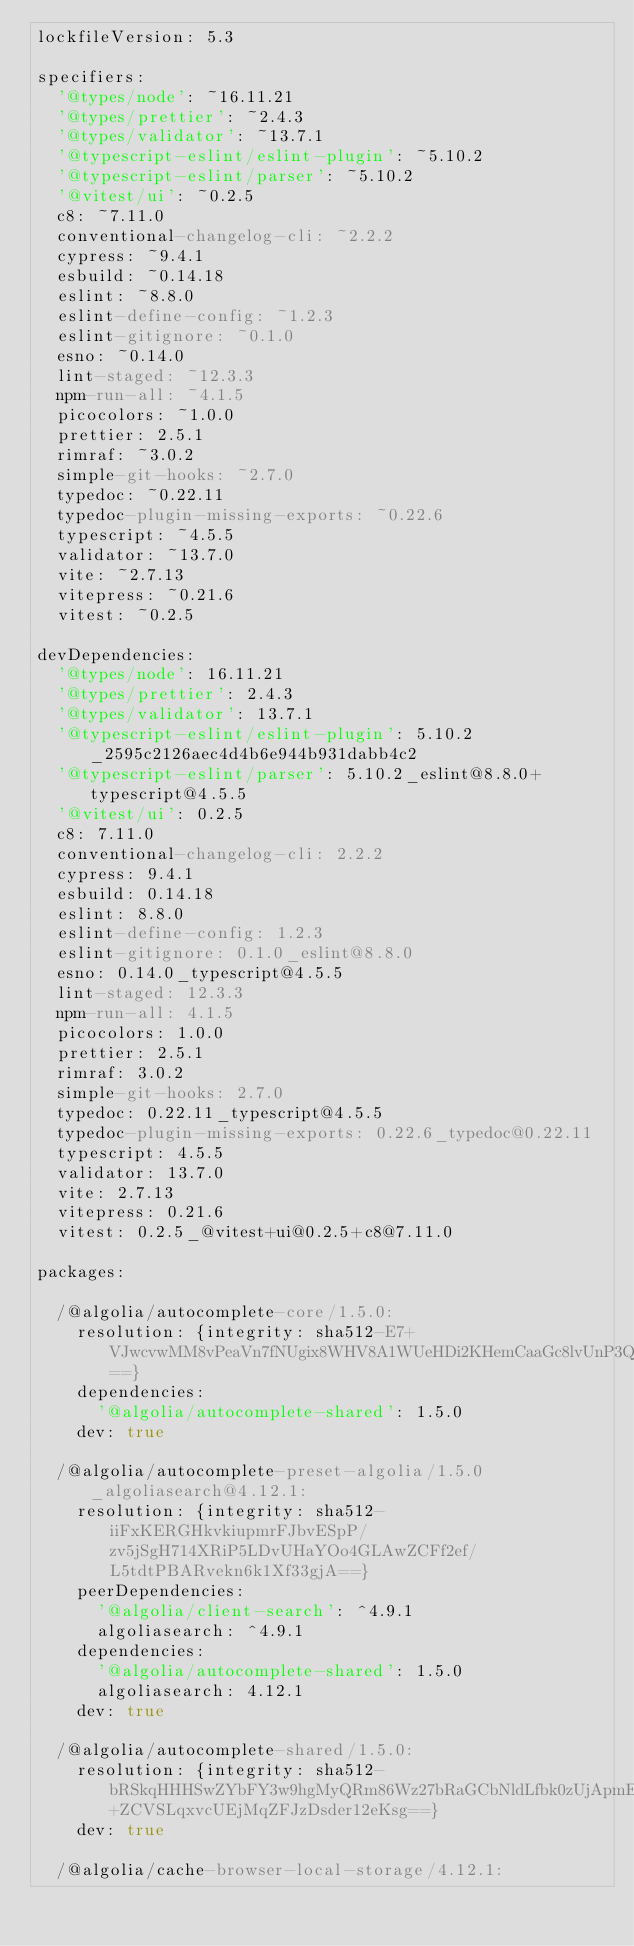Convert code to text. <code><loc_0><loc_0><loc_500><loc_500><_YAML_>lockfileVersion: 5.3

specifiers:
  '@types/node': ~16.11.21
  '@types/prettier': ~2.4.3
  '@types/validator': ~13.7.1
  '@typescript-eslint/eslint-plugin': ~5.10.2
  '@typescript-eslint/parser': ~5.10.2
  '@vitest/ui': ~0.2.5
  c8: ~7.11.0
  conventional-changelog-cli: ~2.2.2
  cypress: ~9.4.1
  esbuild: ~0.14.18
  eslint: ~8.8.0
  eslint-define-config: ~1.2.3
  eslint-gitignore: ~0.1.0
  esno: ~0.14.0
  lint-staged: ~12.3.3
  npm-run-all: ~4.1.5
  picocolors: ~1.0.0
  prettier: 2.5.1
  rimraf: ~3.0.2
  simple-git-hooks: ~2.7.0
  typedoc: ~0.22.11
  typedoc-plugin-missing-exports: ~0.22.6
  typescript: ~4.5.5
  validator: ~13.7.0
  vite: ~2.7.13
  vitepress: ~0.21.6
  vitest: ~0.2.5

devDependencies:
  '@types/node': 16.11.21
  '@types/prettier': 2.4.3
  '@types/validator': 13.7.1
  '@typescript-eslint/eslint-plugin': 5.10.2_2595c2126aec4d4b6e944b931dabb4c2
  '@typescript-eslint/parser': 5.10.2_eslint@8.8.0+typescript@4.5.5
  '@vitest/ui': 0.2.5
  c8: 7.11.0
  conventional-changelog-cli: 2.2.2
  cypress: 9.4.1
  esbuild: 0.14.18
  eslint: 8.8.0
  eslint-define-config: 1.2.3
  eslint-gitignore: 0.1.0_eslint@8.8.0
  esno: 0.14.0_typescript@4.5.5
  lint-staged: 12.3.3
  npm-run-all: 4.1.5
  picocolors: 1.0.0
  prettier: 2.5.1
  rimraf: 3.0.2
  simple-git-hooks: 2.7.0
  typedoc: 0.22.11_typescript@4.5.5
  typedoc-plugin-missing-exports: 0.22.6_typedoc@0.22.11
  typescript: 4.5.5
  validator: 13.7.0
  vite: 2.7.13
  vitepress: 0.21.6
  vitest: 0.2.5_@vitest+ui@0.2.5+c8@7.11.0

packages:

  /@algolia/autocomplete-core/1.5.0:
    resolution: {integrity: sha512-E7+VJwcvwMM8vPeaVn7fNUgix8WHV8A1WUeHDi2KHemCaaGc8lvUnP3QnvhMxiDhTe7OpMEv4o2TBUMyDgThaw==}
    dependencies:
      '@algolia/autocomplete-shared': 1.5.0
    dev: true

  /@algolia/autocomplete-preset-algolia/1.5.0_algoliasearch@4.12.1:
    resolution: {integrity: sha512-iiFxKERGHkvkiupmrFJbvESpP/zv5jSgH714XRiP5LDvUHaYOo4GLAwZCFf2ef/L5tdtPBARvekn6k1Xf33gjA==}
    peerDependencies:
      '@algolia/client-search': ^4.9.1
      algoliasearch: ^4.9.1
    dependencies:
      '@algolia/autocomplete-shared': 1.5.0
      algoliasearch: 4.12.1
    dev: true

  /@algolia/autocomplete-shared/1.5.0:
    resolution: {integrity: sha512-bRSkqHHHSwZYbFY3w9hgMyQRm86Wz27bRaGCbNldLfbk0zUjApmE4ajx+ZCVSLqxvcUEjMqZFJzDsder12eKsg==}
    dev: true

  /@algolia/cache-browser-local-storage/4.12.1:</code> 